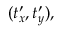<formula> <loc_0><loc_0><loc_500><loc_500>( t _ { x } ^ { \prime } , t _ { y } ^ { \prime } ) ,</formula> 